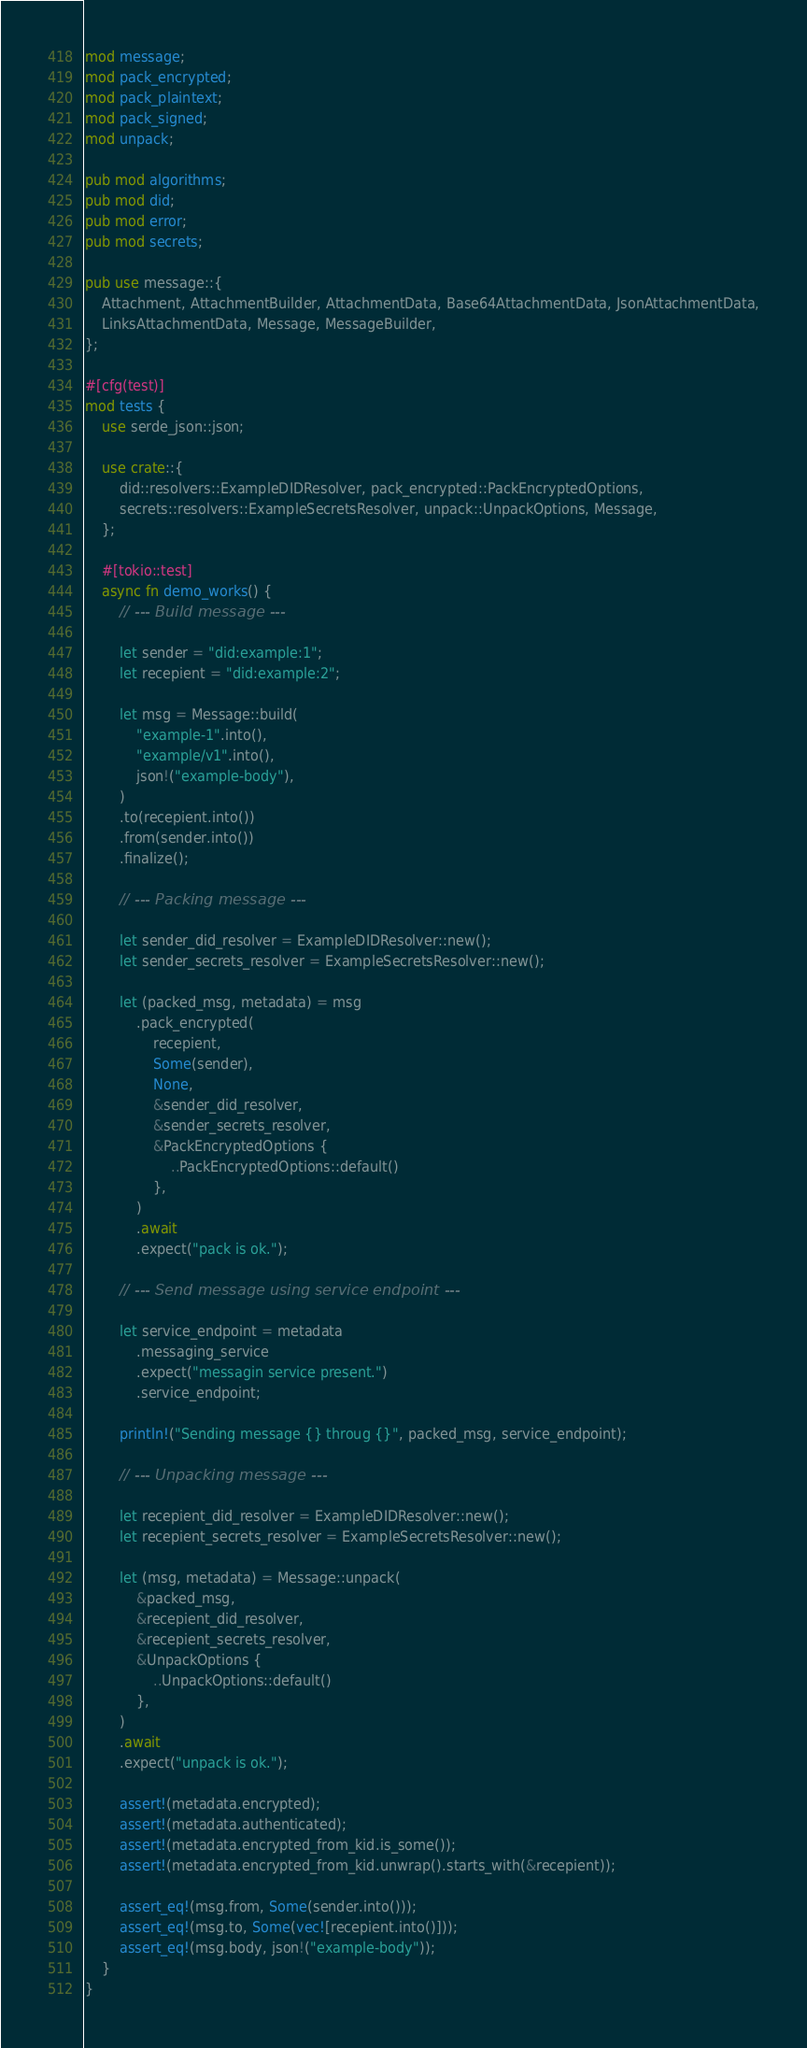Convert code to text. <code><loc_0><loc_0><loc_500><loc_500><_Rust_>mod message;
mod pack_encrypted;
mod pack_plaintext;
mod pack_signed;
mod unpack;

pub mod algorithms;
pub mod did;
pub mod error;
pub mod secrets;

pub use message::{
    Attachment, AttachmentBuilder, AttachmentData, Base64AttachmentData, JsonAttachmentData,
    LinksAttachmentData, Message, MessageBuilder,
};

#[cfg(test)]
mod tests {
    use serde_json::json;

    use crate::{
        did::resolvers::ExampleDIDResolver, pack_encrypted::PackEncryptedOptions,
        secrets::resolvers::ExampleSecretsResolver, unpack::UnpackOptions, Message,
    };

    #[tokio::test]
    async fn demo_works() {
        // --- Build message ---

        let sender = "did:example:1";
        let recepient = "did:example:2";

        let msg = Message::build(
            "example-1".into(),
            "example/v1".into(),
            json!("example-body"),
        )
        .to(recepient.into())
        .from(sender.into())
        .finalize();

        // --- Packing message ---

        let sender_did_resolver = ExampleDIDResolver::new();
        let sender_secrets_resolver = ExampleSecretsResolver::new();

        let (packed_msg, metadata) = msg
            .pack_encrypted(
                recepient,
                Some(sender),
                None,
                &sender_did_resolver,
                &sender_secrets_resolver,
                &PackEncryptedOptions {
                    ..PackEncryptedOptions::default()
                },
            )
            .await
            .expect("pack is ok.");

        // --- Send message using service endpoint ---

        let service_endpoint = metadata
            .messaging_service
            .expect("messagin service present.")
            .service_endpoint;

        println!("Sending message {} throug {}", packed_msg, service_endpoint);

        // --- Unpacking message ---

        let recepient_did_resolver = ExampleDIDResolver::new();
        let recepient_secrets_resolver = ExampleSecretsResolver::new();

        let (msg, metadata) = Message::unpack(
            &packed_msg,
            &recepient_did_resolver,
            &recepient_secrets_resolver,
            &UnpackOptions {
                ..UnpackOptions::default()
            },
        )
        .await
        .expect("unpack is ok.");

        assert!(metadata.encrypted);
        assert!(metadata.authenticated);
        assert!(metadata.encrypted_from_kid.is_some());
        assert!(metadata.encrypted_from_kid.unwrap().starts_with(&recepient));

        assert_eq!(msg.from, Some(sender.into()));
        assert_eq!(msg.to, Some(vec![recepient.into()]));
        assert_eq!(msg.body, json!("example-body"));
    }
}
</code> 